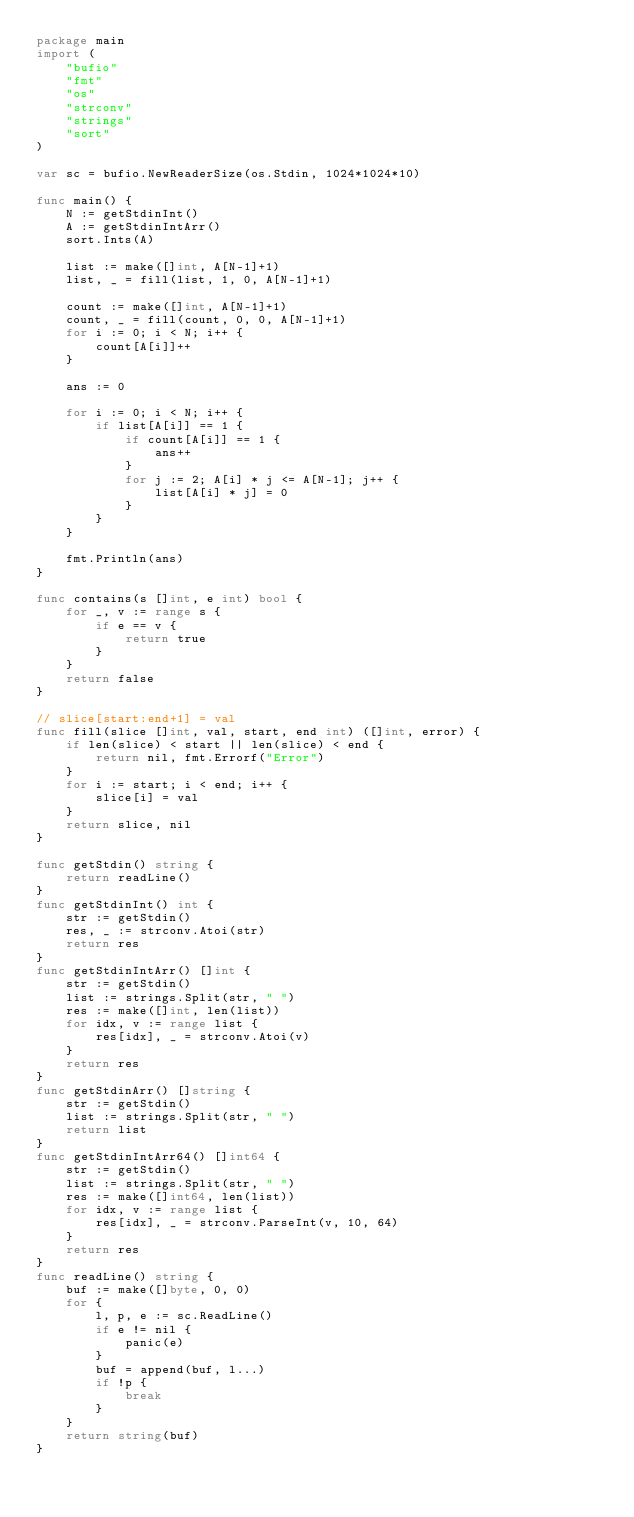<code> <loc_0><loc_0><loc_500><loc_500><_Go_>package main
import (
    "bufio"
    "fmt"
    "os"
    "strconv"
    "strings"
    "sort"
)

var sc = bufio.NewReaderSize(os.Stdin, 1024*1024*10)

func main() {
    N := getStdinInt()
    A := getStdinIntArr()
    sort.Ints(A)

    list := make([]int, A[N-1]+1)
    list, _ = fill(list, 1, 0, A[N-1]+1)

    count := make([]int, A[N-1]+1)
    count, _ = fill(count, 0, 0, A[N-1]+1)
    for i := 0; i < N; i++ {
        count[A[i]]++
    }

    ans := 0

    for i := 0; i < N; i++ {
        if list[A[i]] == 1 {
            if count[A[i]] == 1 {
                ans++
            }
            for j := 2; A[i] * j <= A[N-1]; j++ {
                list[A[i] * j] = 0
            }
        }
    }

    fmt.Println(ans)
}

func contains(s []int, e int) bool {
    for _, v := range s {
        if e == v {
            return true
        }
    }
    return false
}

// slice[start:end+1] = val
func fill(slice []int, val, start, end int) ([]int, error) {
    if len(slice) < start || len(slice) < end {
        return nil, fmt.Errorf("Error")
    }
    for i := start; i < end; i++ {
        slice[i] = val
    }
    return slice, nil
}

func getStdin() string {
    return readLine()
}
func getStdinInt() int {
    str := getStdin()
    res, _ := strconv.Atoi(str)
    return res
}
func getStdinIntArr() []int {
    str := getStdin()
    list := strings.Split(str, " ")
    res := make([]int, len(list))
    for idx, v := range list {
        res[idx], _ = strconv.Atoi(v)
    }
    return res
}
func getStdinArr() []string {
    str := getStdin()
    list := strings.Split(str, " ")
    return list
}
func getStdinIntArr64() []int64 {
    str := getStdin()
    list := strings.Split(str, " ")
    res := make([]int64, len(list))
    for idx, v := range list {
        res[idx], _ = strconv.ParseInt(v, 10, 64)
    }
    return res
}
func readLine() string {
    buf := make([]byte, 0, 0)
    for {
        l, p, e := sc.ReadLine()
        if e != nil {
            panic(e)
        }
        buf = append(buf, l...)
        if !p {
            break
        }
    }
    return string(buf)
}</code> 